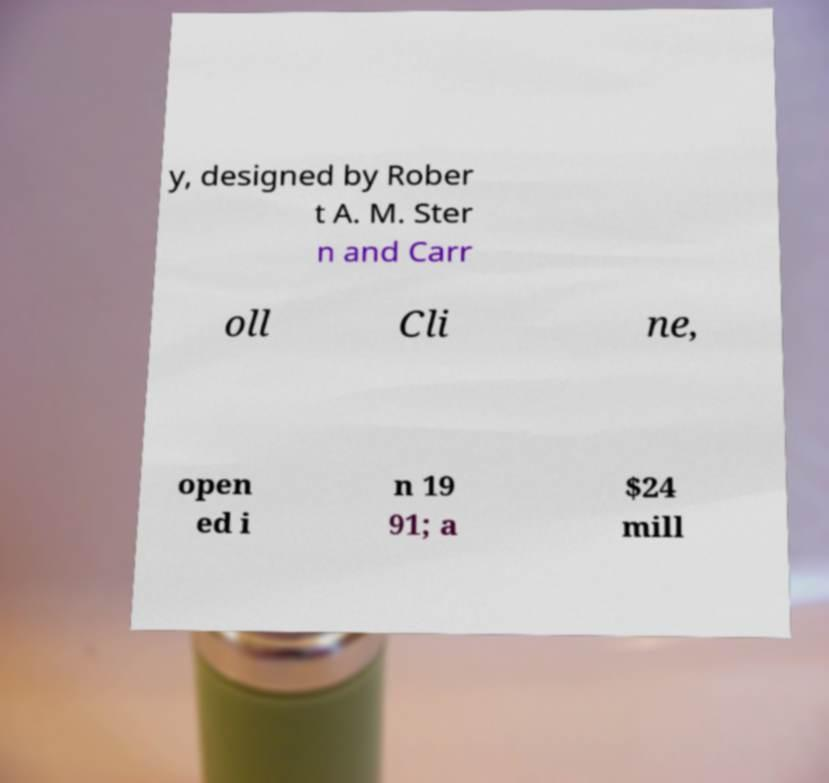I need the written content from this picture converted into text. Can you do that? y, designed by Rober t A. M. Ster n and Carr oll Cli ne, open ed i n 19 91; a $24 mill 